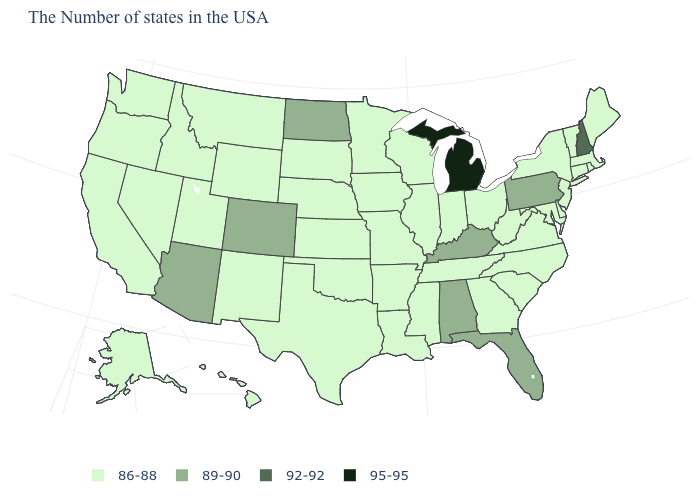How many symbols are there in the legend?
Keep it brief. 4. What is the value of Connecticut?
Be succinct. 86-88. What is the lowest value in the USA?
Keep it brief. 86-88. What is the value of Rhode Island?
Answer briefly. 86-88. Does North Carolina have the same value as Idaho?
Short answer required. Yes. Which states hav the highest value in the South?
Write a very short answer. Florida, Kentucky, Alabama. Does the map have missing data?
Give a very brief answer. No. What is the value of Rhode Island?
Give a very brief answer. 86-88. What is the lowest value in the West?
Short answer required. 86-88. Which states have the lowest value in the West?
Write a very short answer. Wyoming, New Mexico, Utah, Montana, Idaho, Nevada, California, Washington, Oregon, Alaska, Hawaii. Among the states that border Tennessee , which have the lowest value?
Quick response, please. Virginia, North Carolina, Georgia, Mississippi, Missouri, Arkansas. What is the highest value in the USA?
Quick response, please. 95-95. Name the states that have a value in the range 92-92?
Keep it brief. New Hampshire. Name the states that have a value in the range 86-88?
Write a very short answer. Maine, Massachusetts, Rhode Island, Vermont, Connecticut, New York, New Jersey, Delaware, Maryland, Virginia, North Carolina, South Carolina, West Virginia, Ohio, Georgia, Indiana, Tennessee, Wisconsin, Illinois, Mississippi, Louisiana, Missouri, Arkansas, Minnesota, Iowa, Kansas, Nebraska, Oklahoma, Texas, South Dakota, Wyoming, New Mexico, Utah, Montana, Idaho, Nevada, California, Washington, Oregon, Alaska, Hawaii. What is the value of West Virginia?
Concise answer only. 86-88. 